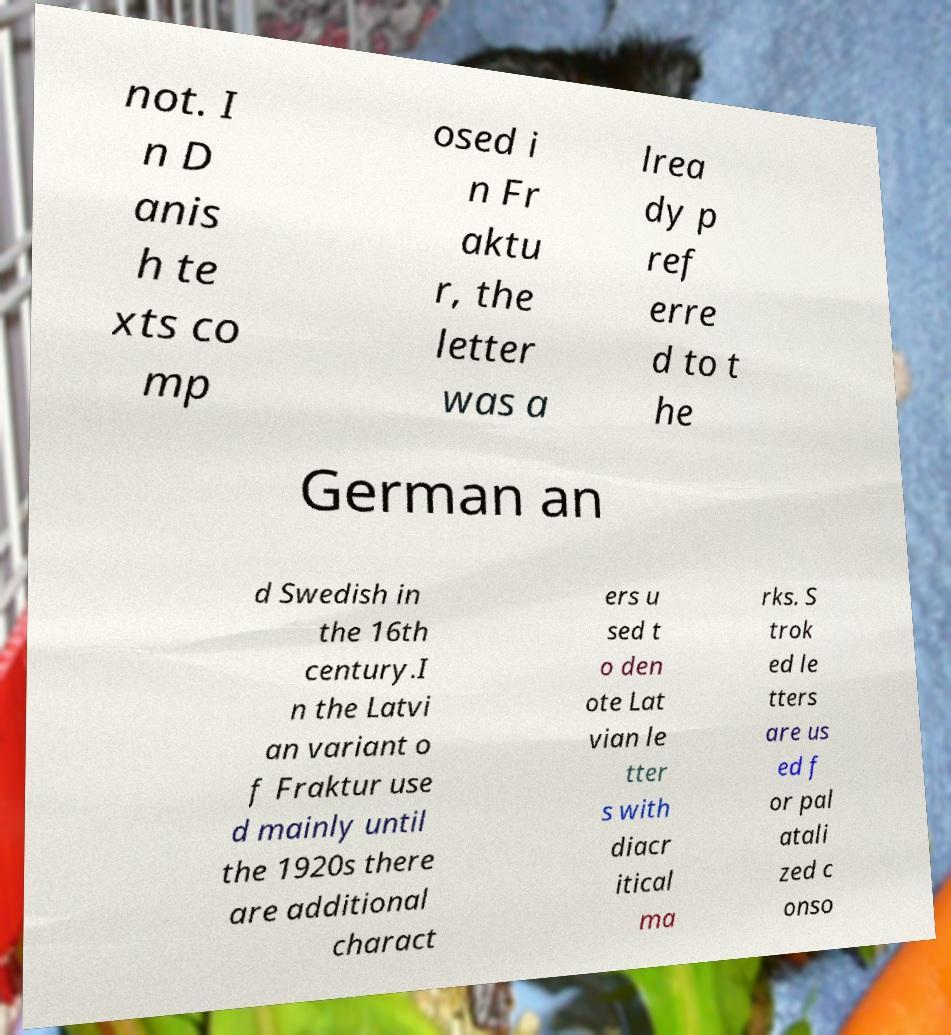Can you read and provide the text displayed in the image?This photo seems to have some interesting text. Can you extract and type it out for me? not. I n D anis h te xts co mp osed i n Fr aktu r, the letter was a lrea dy p ref erre d to t he German an d Swedish in the 16th century.I n the Latvi an variant o f Fraktur use d mainly until the 1920s there are additional charact ers u sed t o den ote Lat vian le tter s with diacr itical ma rks. S trok ed le tters are us ed f or pal atali zed c onso 